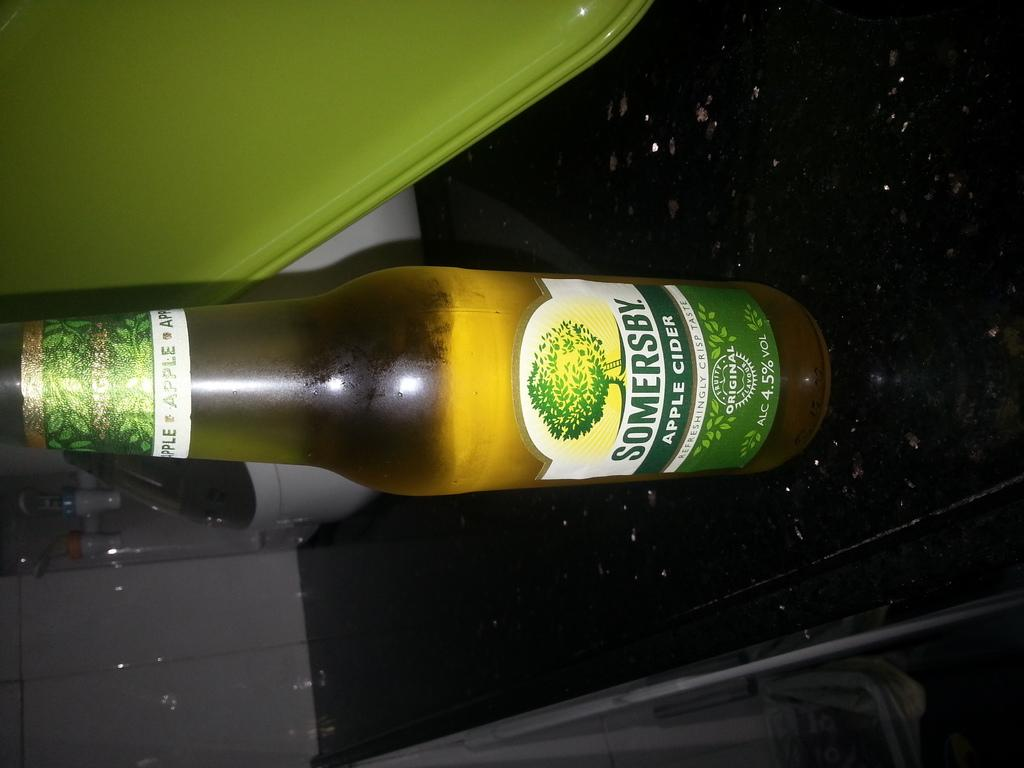<image>
Summarize the visual content of the image. A bottle of Somersby Apple cider with a tree on the lable 